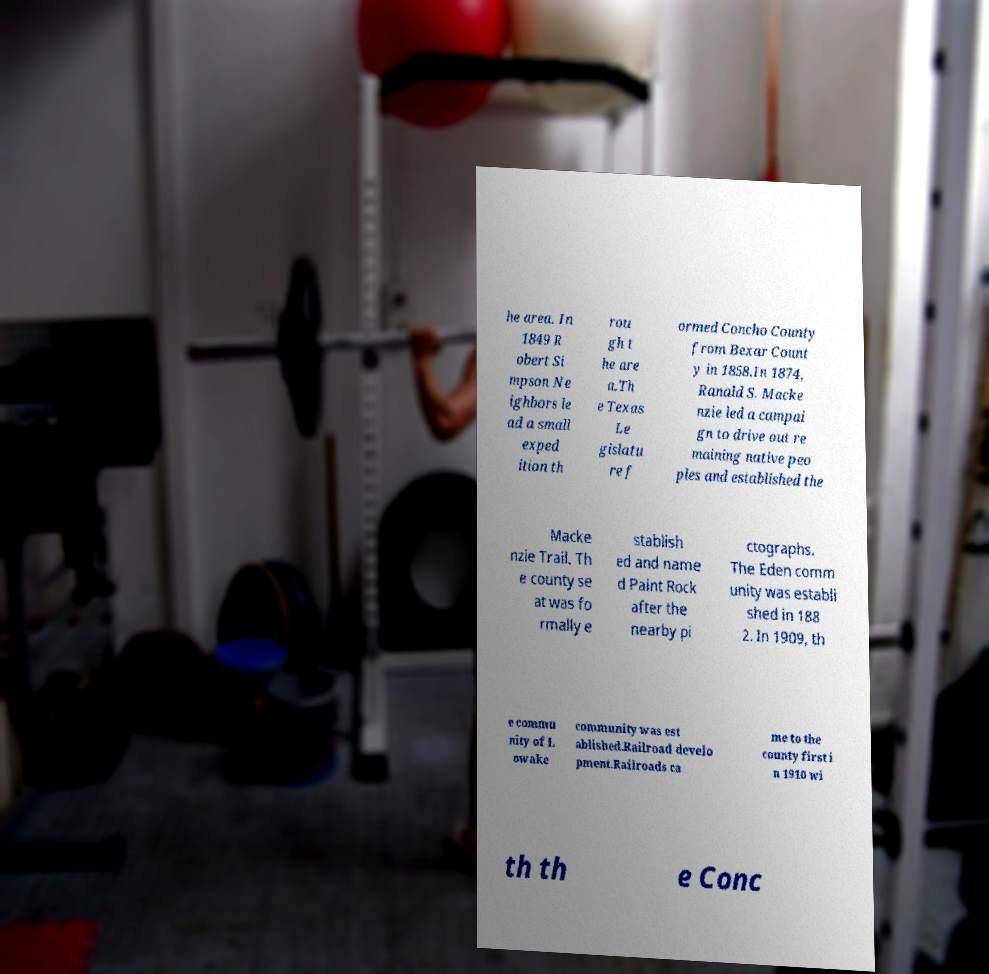What messages or text are displayed in this image? I need them in a readable, typed format. he area. In 1849 R obert Si mpson Ne ighbors le ad a small exped ition th rou gh t he are a.Th e Texas Le gislatu re f ormed Concho County from Bexar Count y in 1858.In 1874, Ranald S. Macke nzie led a campai gn to drive out re maining native peo ples and established the Macke nzie Trail. Th e county se at was fo rmally e stablish ed and name d Paint Rock after the nearby pi ctographs. The Eden comm unity was establi shed in 188 2. In 1909, th e commu nity of L owake community was est ablished.Railroad develo pment.Railroads ca me to the county first i n 1910 wi th th e Conc 